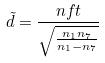Convert formula to latex. <formula><loc_0><loc_0><loc_500><loc_500>\tilde { d } = \frac { n f t } { \sqrt { \frac { n _ { 1 } n _ { 7 } } { n _ { 1 } - n _ { 7 } } } }</formula> 